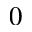Convert formula to latex. <formula><loc_0><loc_0><loc_500><loc_500>0</formula> 